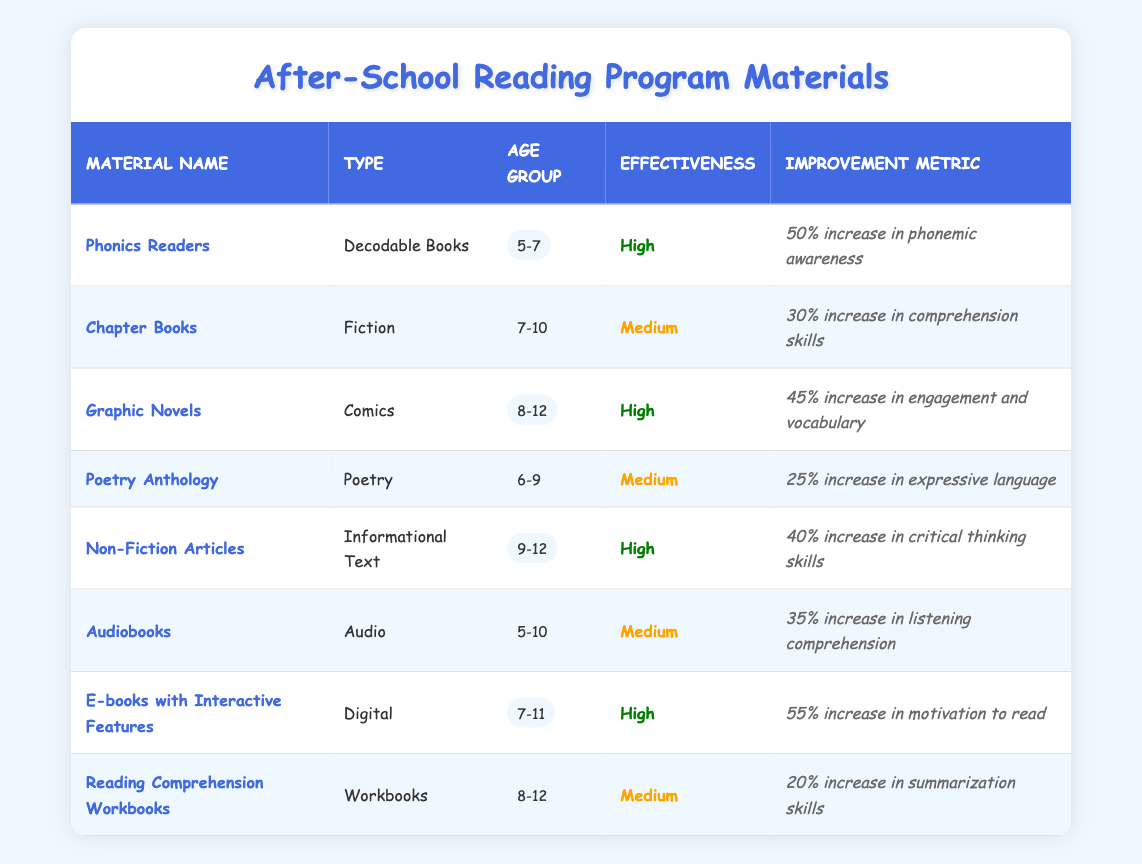What is the effectiveness rating of Graphic Novels? According to the table, the effectiveness rating for Graphic Novels is listed under the "Effectiveness" column, showing "High."
Answer: High Which age group uses Phonics Readers? The age group corresponding to Phonics Readers can be found in the "Age Group" column, where it is noted as "5-7."
Answer: 5-7 How many types of reading materials are rated as High in effectiveness? By reviewing the "Effectiveness" column, we can count the number of materials marked as "High." In total, there are four items: Phonics Readers, Graphic Novels, Non-Fiction Articles, and E-books with Interactive Features.
Answer: 4 Is the effectiveness of Audiobooks Medium? Checking the "Effectiveness" column for Audiobooks reveals that it is indeed marked as "Medium." Therefore, the statement is true.
Answer: Yes What is the improvement metric associated with E-books with Interactive Features? Referring to the "Improvement Metric" column, we can see that E-books with Interactive Features show an improvement of "55% increase in motivation to read."
Answer: 55% increase in motivation to read Which reading material has the highest improvement metric? To find this, we look through the "Improvement Metric" column and compare the values. E-books with Interactive Features has "55% increase," which is the highest among all materials listed.
Answer: E-books with Interactive Features What is the average percentage increase in skills for materials rated as Medium? The materials rated as Medium include Chapter Books (30%), Poetry Anthology (25%), Audiobooks (35%), and Reading Comprehension Workbooks (20%). The total is 30 + 25 + 35 + 20 = 110. There are 4 datasets, so we divide 110 by 4, giving us an average of 27.5%.
Answer: 27.5% Are all the reading materials for ages 5-10 rated as High in effectiveness? Looking at the table, we see that both Phonics Readers and Audiobooks are for ages 5-10, but Audiobooks is rated as Medium. Therefore, the claim is false.
Answer: No 